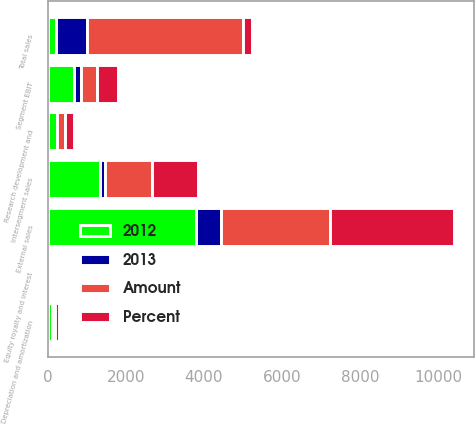<chart> <loc_0><loc_0><loc_500><loc_500><stacked_bar_chart><ecel><fcel>External sales<fcel>Intersegment sales<fcel>Total sales<fcel>Depreciation and amortization<fcel>Research development and<fcel>Equity royalty and interest<fcel>Segment EBIT<nl><fcel>2012<fcel>3791<fcel>1327<fcel>224<fcel>106<fcel>230<fcel>36<fcel>684<nl><fcel>Percent<fcel>3151<fcel>1191<fcel>224<fcel>96<fcel>218<fcel>28<fcel>527<nl><fcel>Amount<fcel>2809<fcel>1203<fcel>4012<fcel>82<fcel>213<fcel>29<fcel>426<nl><fcel>2013<fcel>640<fcel>136<fcel>776<fcel>10<fcel>12<fcel>8<fcel>157<nl></chart> 